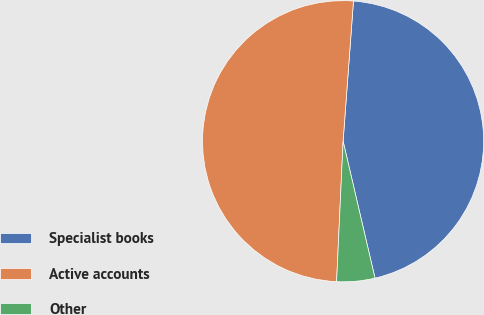Convert chart. <chart><loc_0><loc_0><loc_500><loc_500><pie_chart><fcel>Specialist books<fcel>Active accounts<fcel>Other<nl><fcel>45.18%<fcel>50.44%<fcel>4.38%<nl></chart> 